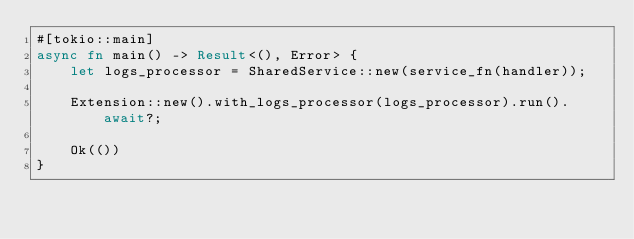<code> <loc_0><loc_0><loc_500><loc_500><_Rust_>#[tokio::main]
async fn main() -> Result<(), Error> {
    let logs_processor = SharedService::new(service_fn(handler));

    Extension::new().with_logs_processor(logs_processor).run().await?;

    Ok(())
}
</code> 